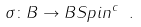Convert formula to latex. <formula><loc_0><loc_0><loc_500><loc_500>\sigma \colon B \to B S p i n ^ { c } \ .</formula> 